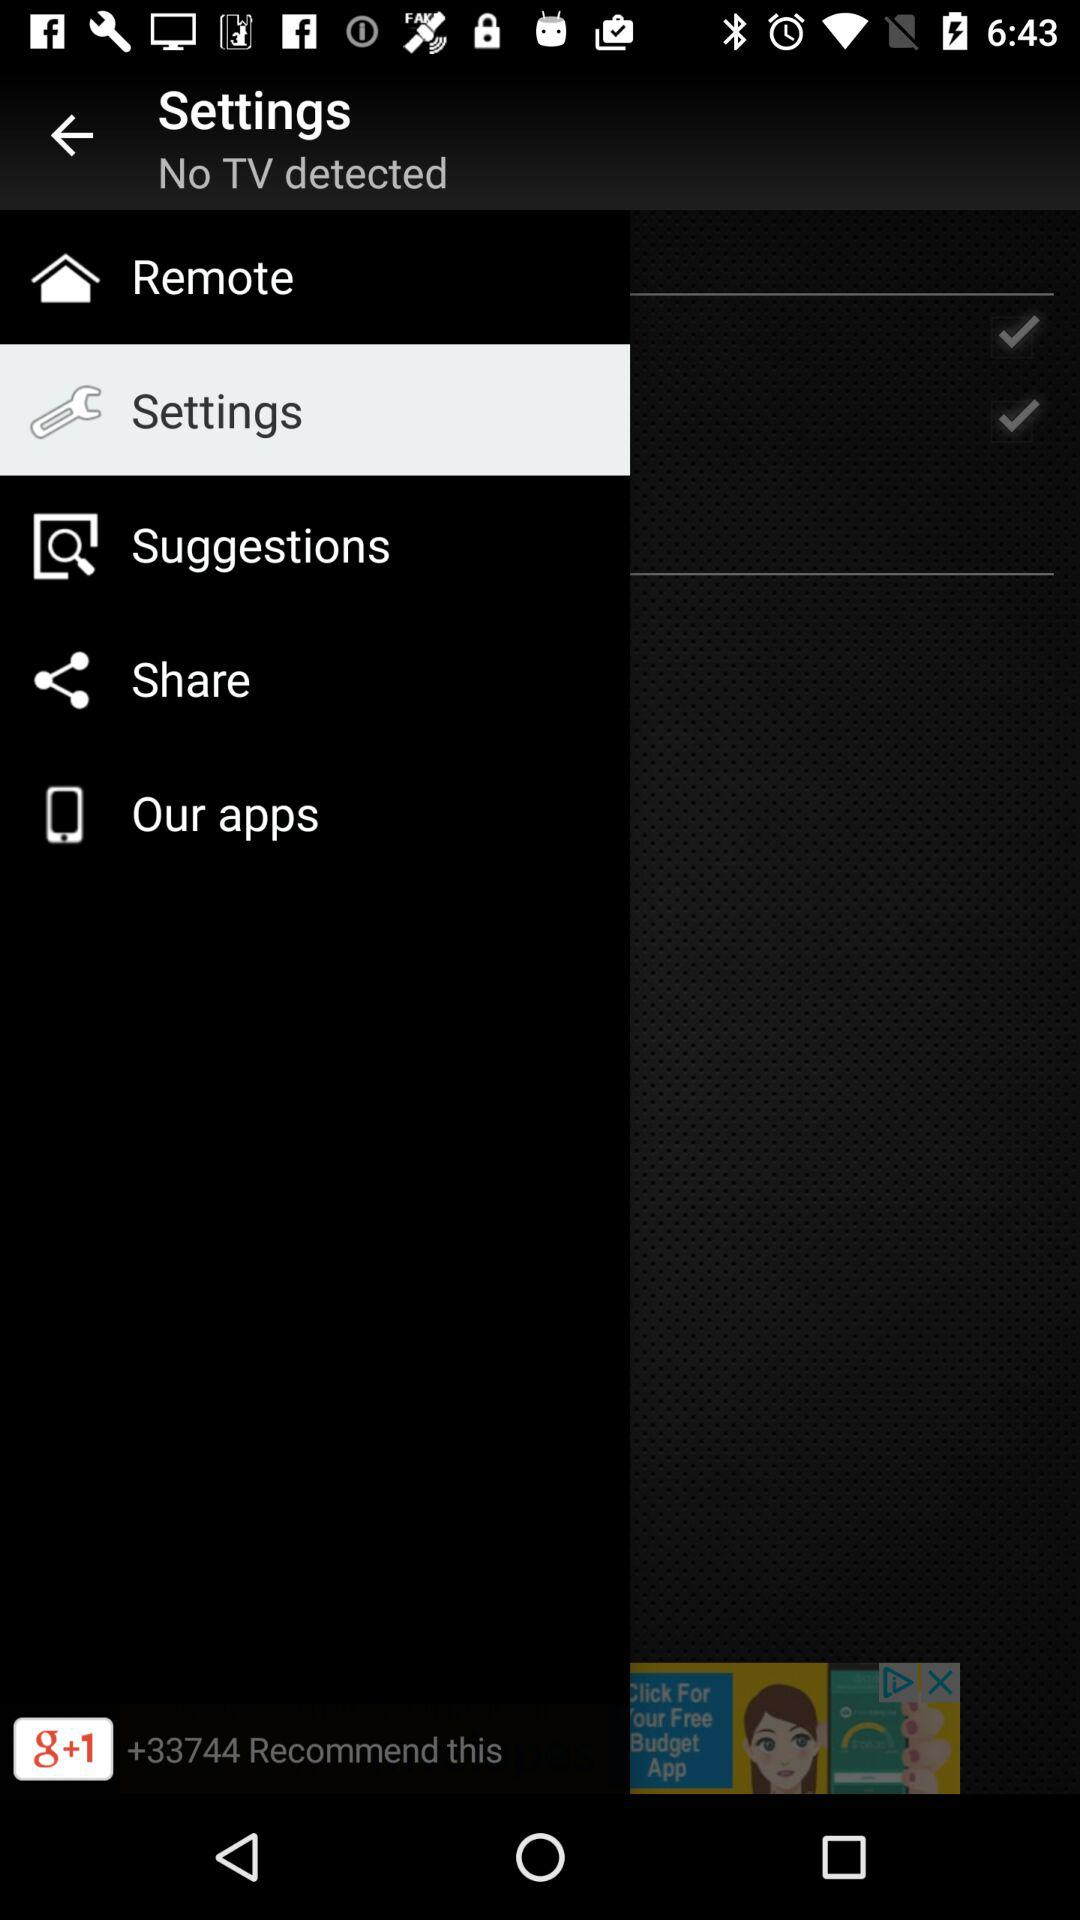How many checkmarks are there on the screen?
Answer the question using a single word or phrase. 2 